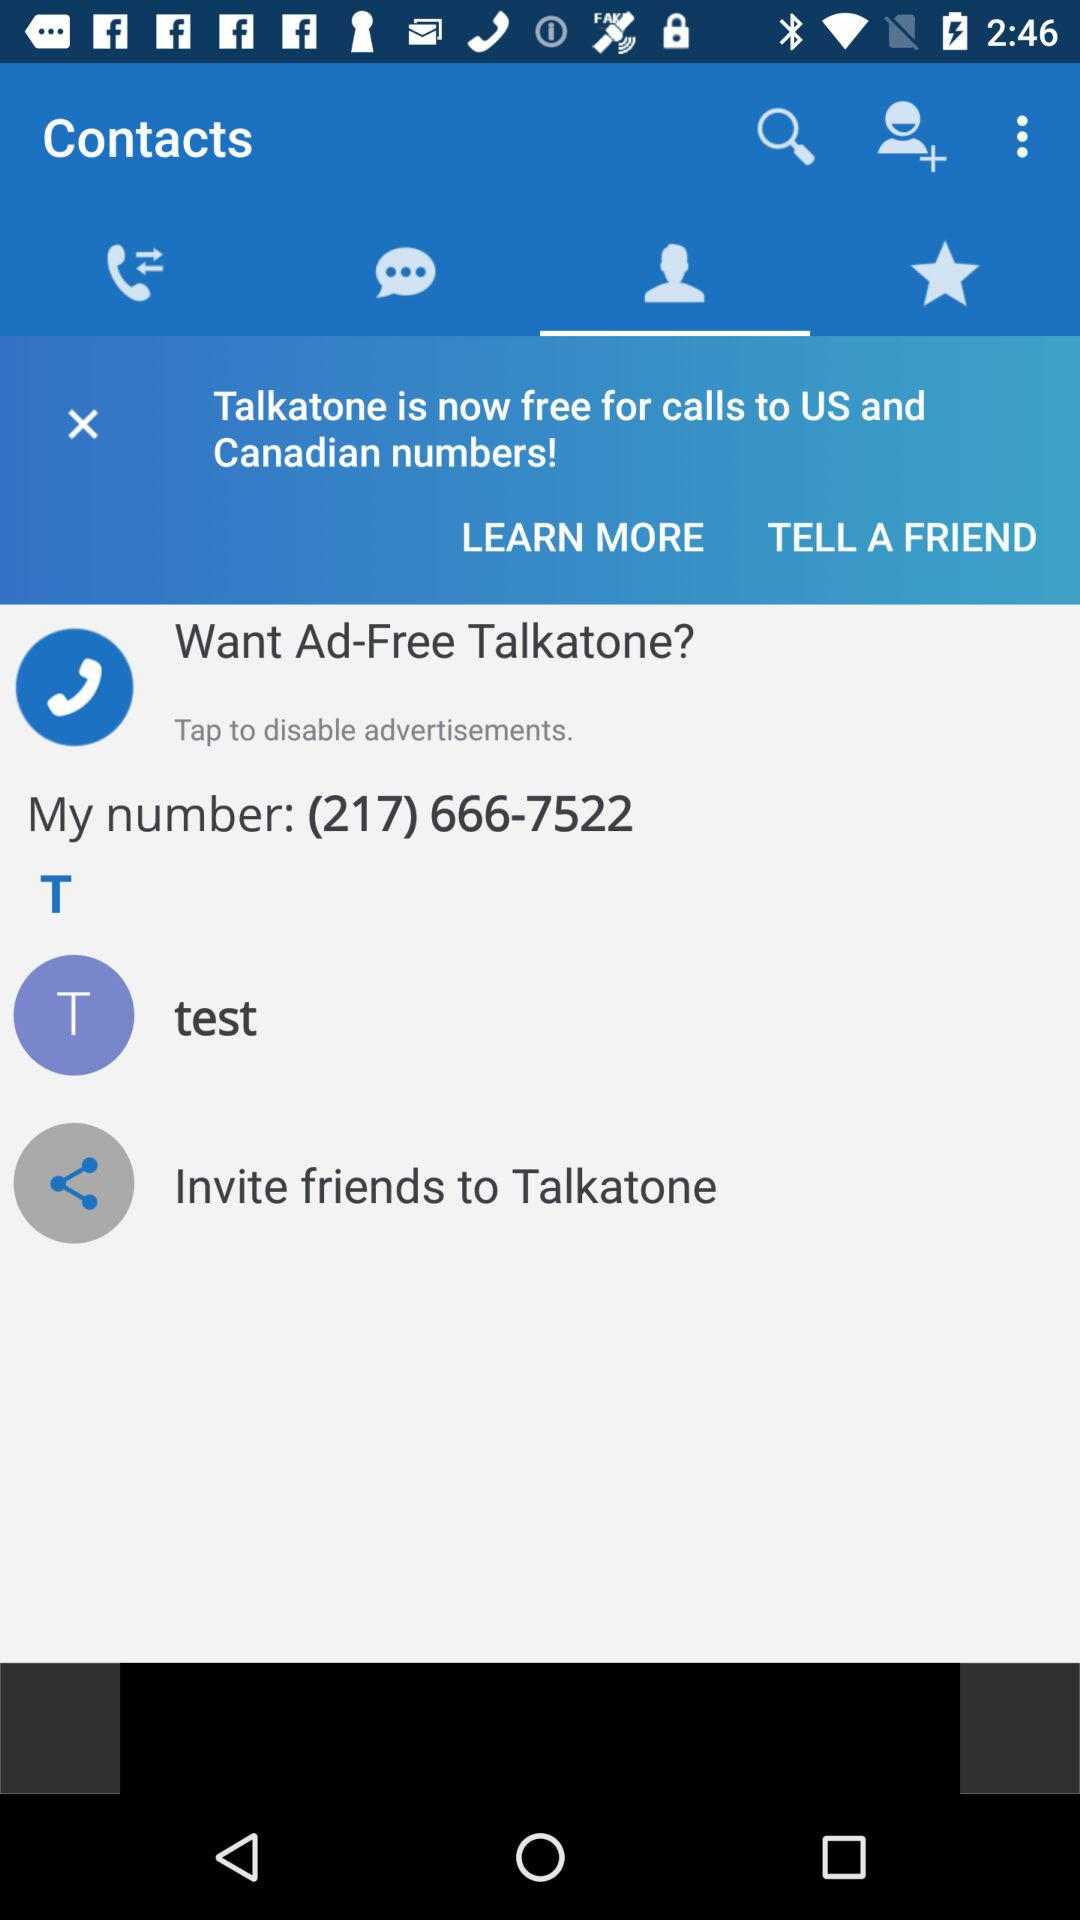Which tab is selected? The selected tab is "Contacts". 